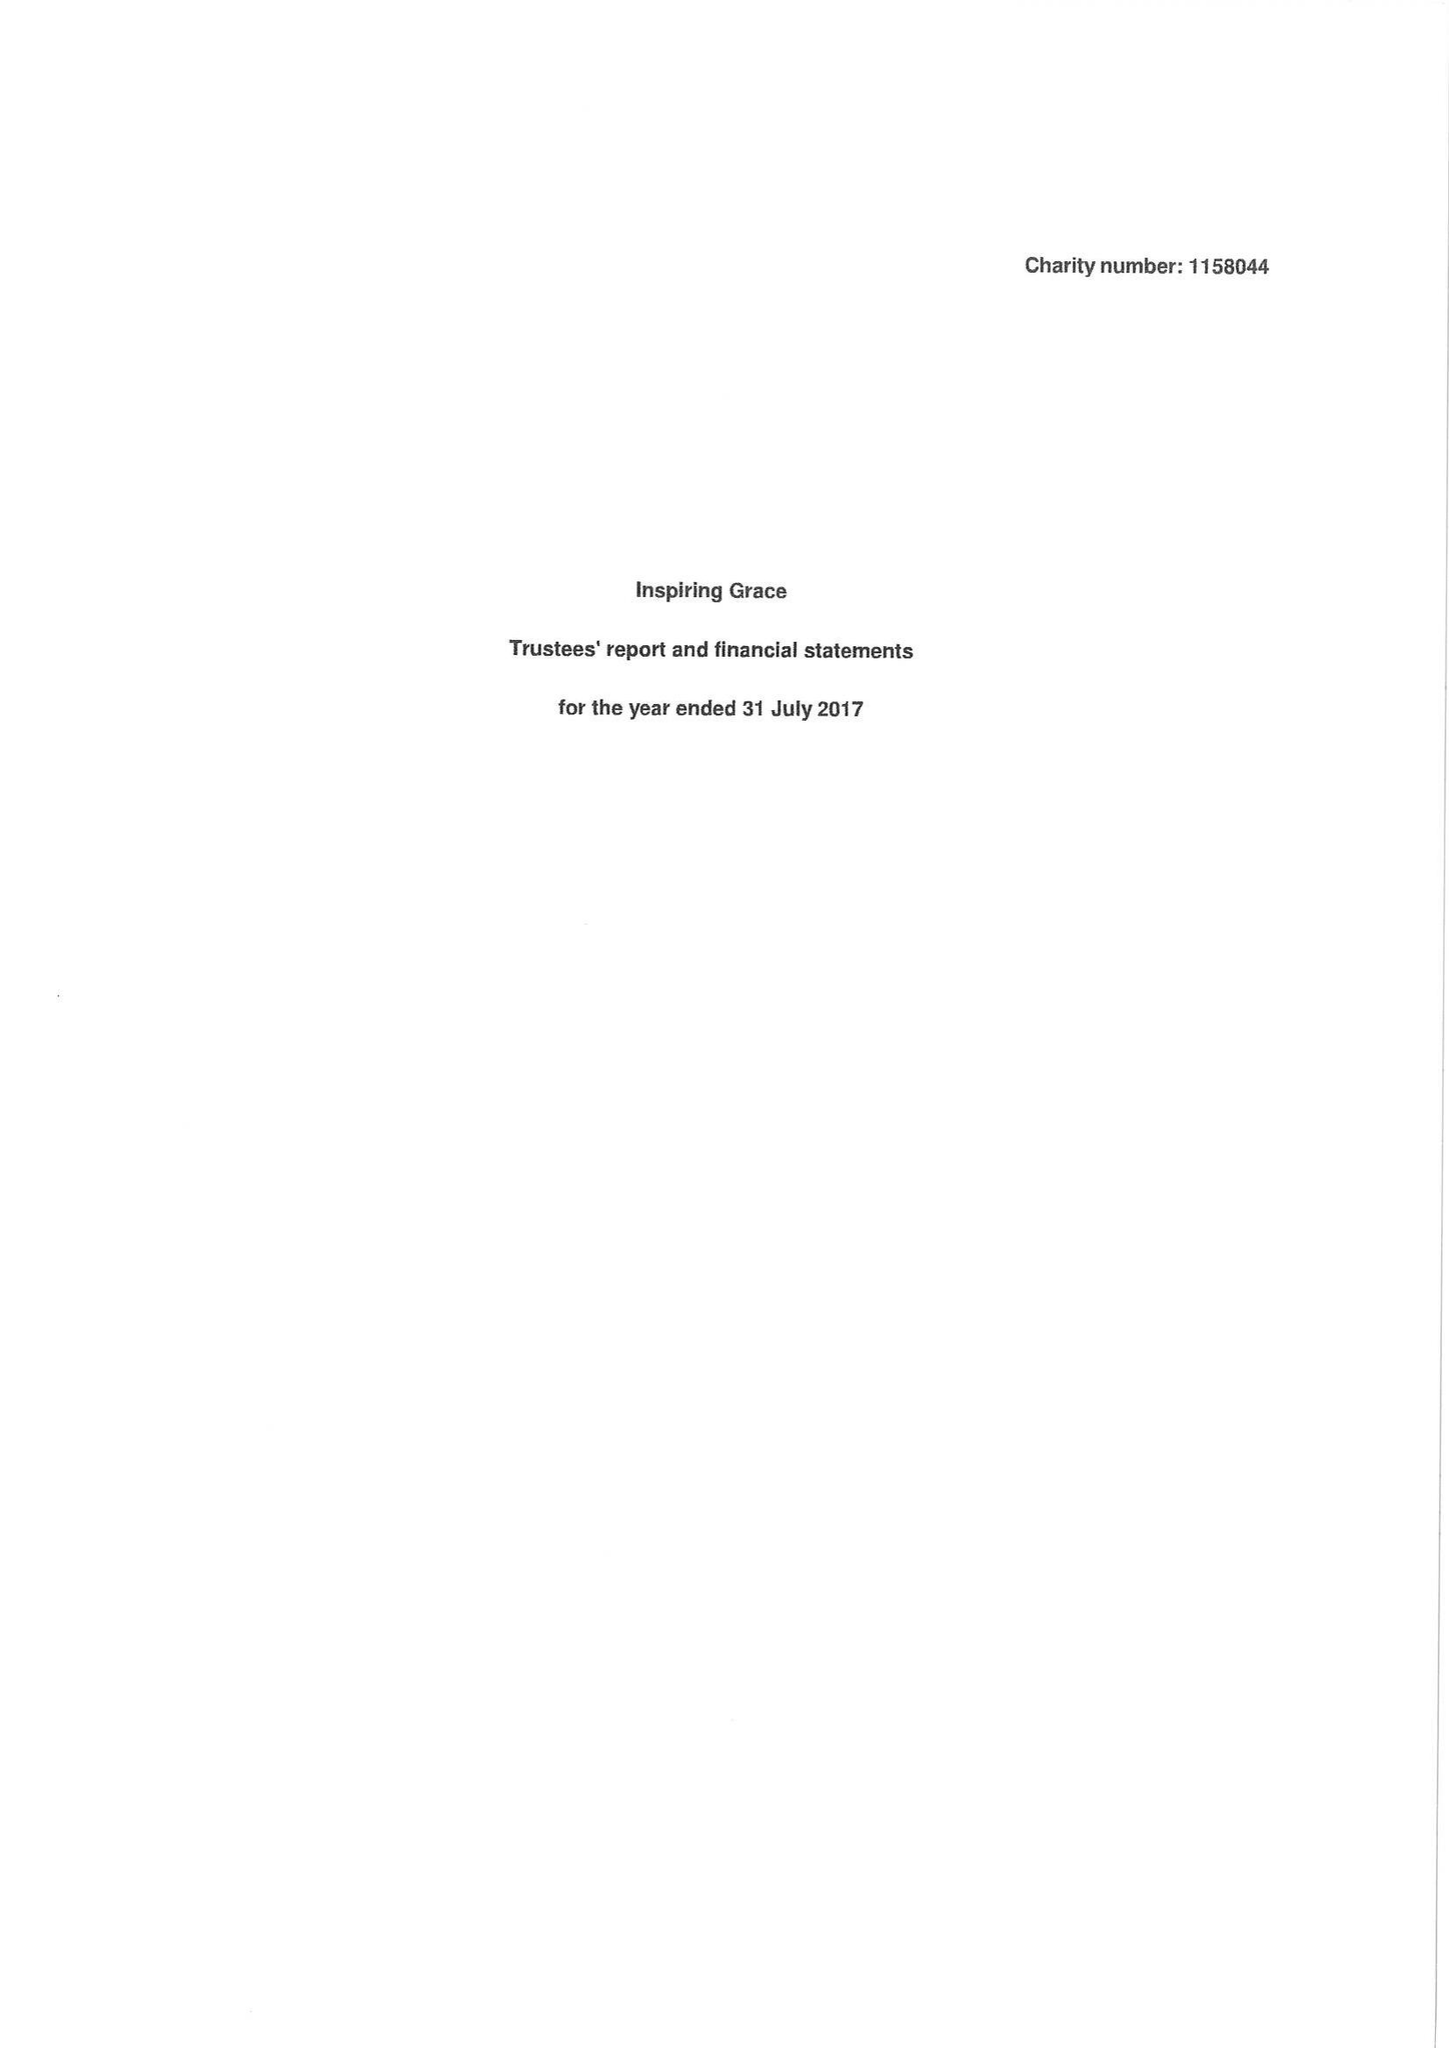What is the value for the address__street_line?
Answer the question using a single word or phrase. 22 EDWARD STREET 